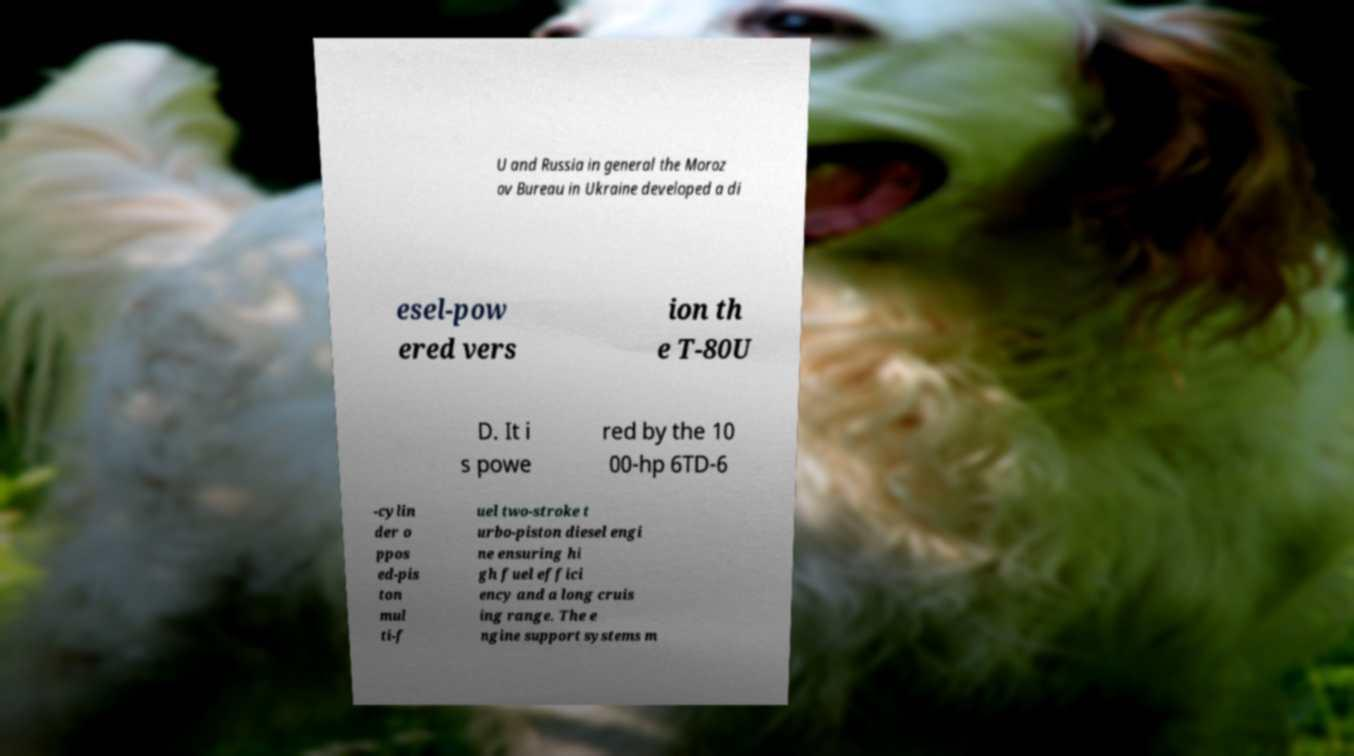Could you assist in decoding the text presented in this image and type it out clearly? U and Russia in general the Moroz ov Bureau in Ukraine developed a di esel-pow ered vers ion th e T-80U D. It i s powe red by the 10 00-hp 6TD-6 -cylin der o ppos ed-pis ton mul ti-f uel two-stroke t urbo-piston diesel engi ne ensuring hi gh fuel effici ency and a long cruis ing range. The e ngine support systems m 